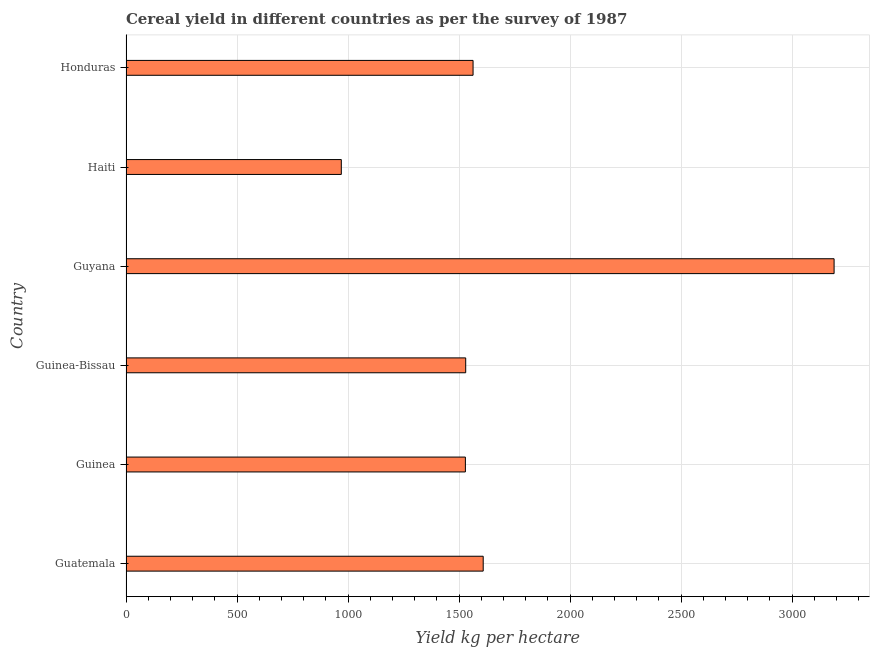What is the title of the graph?
Offer a terse response. Cereal yield in different countries as per the survey of 1987. What is the label or title of the X-axis?
Keep it short and to the point. Yield kg per hectare. What is the label or title of the Y-axis?
Provide a short and direct response. Country. What is the cereal yield in Guatemala?
Ensure brevity in your answer.  1608.82. Across all countries, what is the maximum cereal yield?
Your answer should be very brief. 3189.25. Across all countries, what is the minimum cereal yield?
Keep it short and to the point. 969.73. In which country was the cereal yield maximum?
Make the answer very short. Guyana. In which country was the cereal yield minimum?
Offer a terse response. Haiti. What is the sum of the cereal yield?
Make the answer very short. 1.04e+04. What is the difference between the cereal yield in Guinea and Honduras?
Make the answer very short. -34.62. What is the average cereal yield per country?
Give a very brief answer. 1731.59. What is the median cereal yield?
Give a very brief answer. 1546.59. In how many countries, is the cereal yield greater than 1500 kg per hectare?
Offer a very short reply. 5. What is the ratio of the cereal yield in Guinea to that in Haiti?
Ensure brevity in your answer.  1.58. Is the cereal yield in Guatemala less than that in Guinea-Bissau?
Your answer should be very brief. No. Is the difference between the cereal yield in Guinea-Bissau and Honduras greater than the difference between any two countries?
Ensure brevity in your answer.  No. What is the difference between the highest and the second highest cereal yield?
Ensure brevity in your answer.  1580.43. Is the sum of the cereal yield in Guyana and Honduras greater than the maximum cereal yield across all countries?
Provide a succinct answer. Yes. What is the difference between the highest and the lowest cereal yield?
Make the answer very short. 2219.52. In how many countries, is the cereal yield greater than the average cereal yield taken over all countries?
Make the answer very short. 1. How many countries are there in the graph?
Keep it short and to the point. 6. What is the Yield kg per hectare in Guatemala?
Ensure brevity in your answer.  1608.82. What is the Yield kg per hectare in Guinea?
Provide a succinct answer. 1528.57. What is the Yield kg per hectare in Guinea-Bissau?
Your response must be concise. 1530. What is the Yield kg per hectare of Guyana?
Your answer should be very brief. 3189.25. What is the Yield kg per hectare of Haiti?
Your response must be concise. 969.73. What is the Yield kg per hectare in Honduras?
Provide a short and direct response. 1563.18. What is the difference between the Yield kg per hectare in Guatemala and Guinea?
Ensure brevity in your answer.  80.25. What is the difference between the Yield kg per hectare in Guatemala and Guinea-Bissau?
Give a very brief answer. 78.82. What is the difference between the Yield kg per hectare in Guatemala and Guyana?
Provide a short and direct response. -1580.43. What is the difference between the Yield kg per hectare in Guatemala and Haiti?
Give a very brief answer. 639.09. What is the difference between the Yield kg per hectare in Guatemala and Honduras?
Ensure brevity in your answer.  45.63. What is the difference between the Yield kg per hectare in Guinea and Guinea-Bissau?
Your answer should be very brief. -1.44. What is the difference between the Yield kg per hectare in Guinea and Guyana?
Offer a terse response. -1660.68. What is the difference between the Yield kg per hectare in Guinea and Haiti?
Give a very brief answer. 558.83. What is the difference between the Yield kg per hectare in Guinea and Honduras?
Offer a very short reply. -34.62. What is the difference between the Yield kg per hectare in Guinea-Bissau and Guyana?
Offer a very short reply. -1659.25. What is the difference between the Yield kg per hectare in Guinea-Bissau and Haiti?
Offer a terse response. 560.27. What is the difference between the Yield kg per hectare in Guinea-Bissau and Honduras?
Offer a terse response. -33.18. What is the difference between the Yield kg per hectare in Guyana and Haiti?
Ensure brevity in your answer.  2219.52. What is the difference between the Yield kg per hectare in Guyana and Honduras?
Provide a succinct answer. 1626.07. What is the difference between the Yield kg per hectare in Haiti and Honduras?
Your response must be concise. -593.45. What is the ratio of the Yield kg per hectare in Guatemala to that in Guinea?
Your response must be concise. 1.05. What is the ratio of the Yield kg per hectare in Guatemala to that in Guinea-Bissau?
Offer a terse response. 1.05. What is the ratio of the Yield kg per hectare in Guatemala to that in Guyana?
Ensure brevity in your answer.  0.5. What is the ratio of the Yield kg per hectare in Guatemala to that in Haiti?
Offer a terse response. 1.66. What is the ratio of the Yield kg per hectare in Guatemala to that in Honduras?
Your response must be concise. 1.03. What is the ratio of the Yield kg per hectare in Guinea to that in Guinea-Bissau?
Your response must be concise. 1. What is the ratio of the Yield kg per hectare in Guinea to that in Guyana?
Provide a short and direct response. 0.48. What is the ratio of the Yield kg per hectare in Guinea to that in Haiti?
Give a very brief answer. 1.58. What is the ratio of the Yield kg per hectare in Guinea-Bissau to that in Guyana?
Provide a short and direct response. 0.48. What is the ratio of the Yield kg per hectare in Guinea-Bissau to that in Haiti?
Make the answer very short. 1.58. What is the ratio of the Yield kg per hectare in Guinea-Bissau to that in Honduras?
Provide a succinct answer. 0.98. What is the ratio of the Yield kg per hectare in Guyana to that in Haiti?
Keep it short and to the point. 3.29. What is the ratio of the Yield kg per hectare in Guyana to that in Honduras?
Give a very brief answer. 2.04. What is the ratio of the Yield kg per hectare in Haiti to that in Honduras?
Make the answer very short. 0.62. 